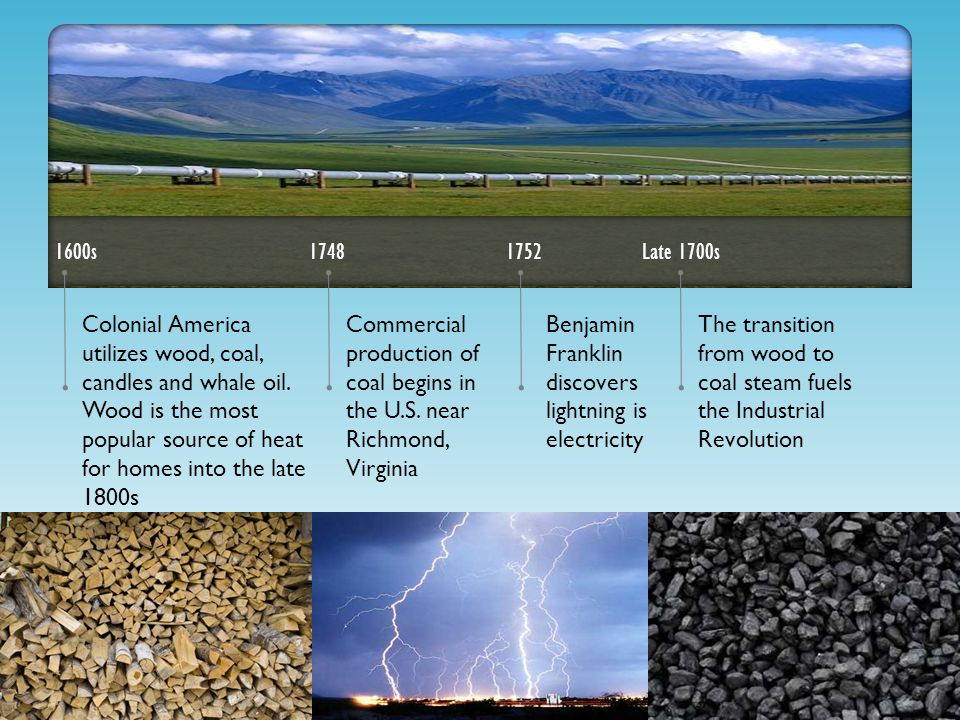If you could harness the power of lightning as Benjamin Franklin first imagined, what modern applications and technologies do you think could have evolved differently? Harnessing the power of lightning, as Benjamin Franklin first conceptualized, could have revolutionized the development of energy technologies. Modern applications could include highly efficient and instantaneous power generation systems able to store and distribute electricity from lightning storms. If this technology were perfected, we might see devices and infrastructure built to capture and utilize the massive amounts of energy discharged during lightning strikes. This could lead to breakthroughs in renewable energy, potentially providing power with minimal environmental impact if energy storage technologies were advanced to keep up. Other futuristic technologies could include ultra-fast charging systems for electric vehicles, specialized grids that can handle the immense power of a lightning strike, and even personal devices powered directly by captured lightning energy, revolutionizing everything from transportation to everyday electronics in a sustainable manner. 